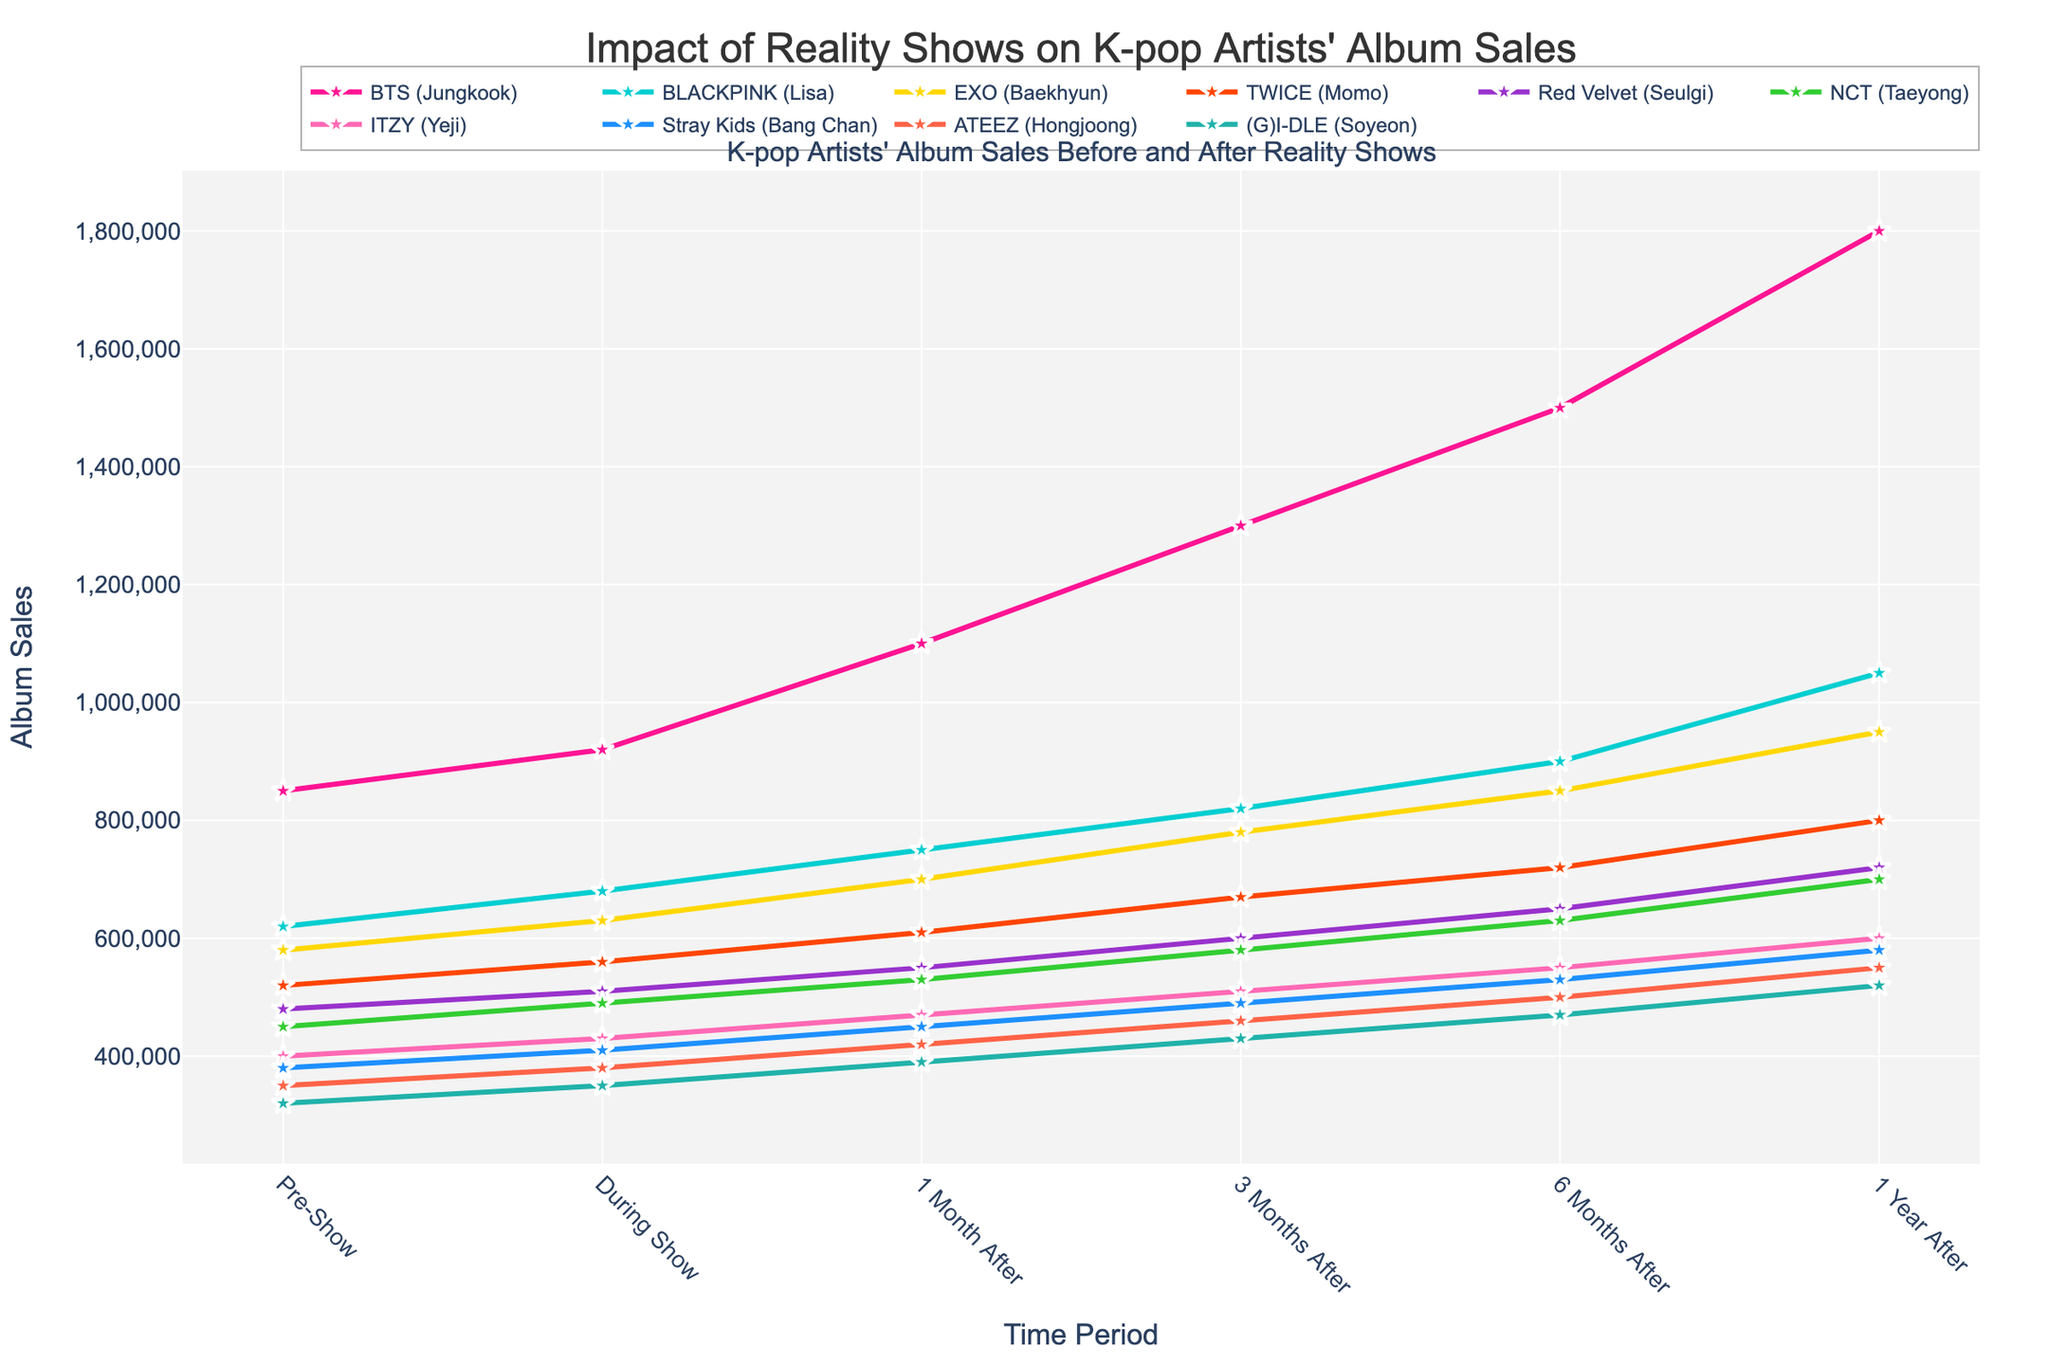Which artist had the highest album sales one year after participating in the reality competition? To find the artist with the highest album sales one year after the reality competition, look at the y-axis values corresponding to "1 Year After" for each artist. The highest value is 1,800,000 for BTS (Jungkook).
Answer: BTS (Jungkook) What is the difference in album sales for BLACKPINK (Lisa) between pre-show and one year after the show? Find the album sales for BLACKPINK (Lisa) during the pre-show period and one year after. The values are 620,000 and 1,050,000 respectively. The difference is 1,050,000 - 620,000 = 430,000.
Answer: 430,000 Which artist's album sales increased the least from the pre-show period to one year after the show? Calculate the difference in album sales from pre-show to one year after for each artist. The smallest difference is for (G)I-DLE (Soyeon), which is 520,000 - 320,000 = 200,000.
Answer: (G)I-DLE (Soyeon) How much more did EXO (Baekhyun) sell during the show compared to ITZY (Yeji) during the same period? Look at the album sales during the show for EXO (Baekhyun) and ITZY (Yeji). The sales are 630,000 and 430,000 respectively. The difference is 630,000 - 430,000 = 200,000.
Answer: 200,000 Which time period shows the most significant increase in album sales for Red Velvet (Seulgi)? Compare the increase in album sales for each time period for Red Velvet (Seulgi). The biggest increase is between "3 Months After" and "6 Months After," where the sales go from 600,000 to 650,000, an increase of 50,000.
Answer: 3 Months After to 6 Months After What is the average album sales of NCT (Taeyong) after the show (including all post-show time periods)? Add the album sales for NCT (Taeyong) for all post-show periods: 530,000 + 580,000 + 630,000 + 700,000 = 2,440,000. Then divide by 4 (number of post-show periods). The average is 2,440,000 / 4 = 610,000.
Answer: 610,000 How do BTS (Jungkook)’s album sales increase from during the show to one year after compare to ITZY (Yeji)'s increase over the same period? Calculate the increase for BTS (Jungkook) from during the show to one year after: 1,800,000 - 920,000 = 880,000. For ITZY (Yeji): 600,000 - 430,000 = 170,000. The difference in increases is 880,000 - 170,000.
Answer: 710,000 Which artist showed a consistent growth pattern every time period without any drop in sales? Reviewing the sales for each artist, BTS (Jungkook), BLACKPINK (Lisa), EXO (Baekhyun), TWICE (Momo), Red Velvet (Seulgi), NCT (Taeyong), ITZY (Yeji), Stray Kids (Bang Chan), ATEEZ (Hongjoong), and (G)I-DLE (Soyeon) all show consistent growth without any drops.
Answer: All artists 